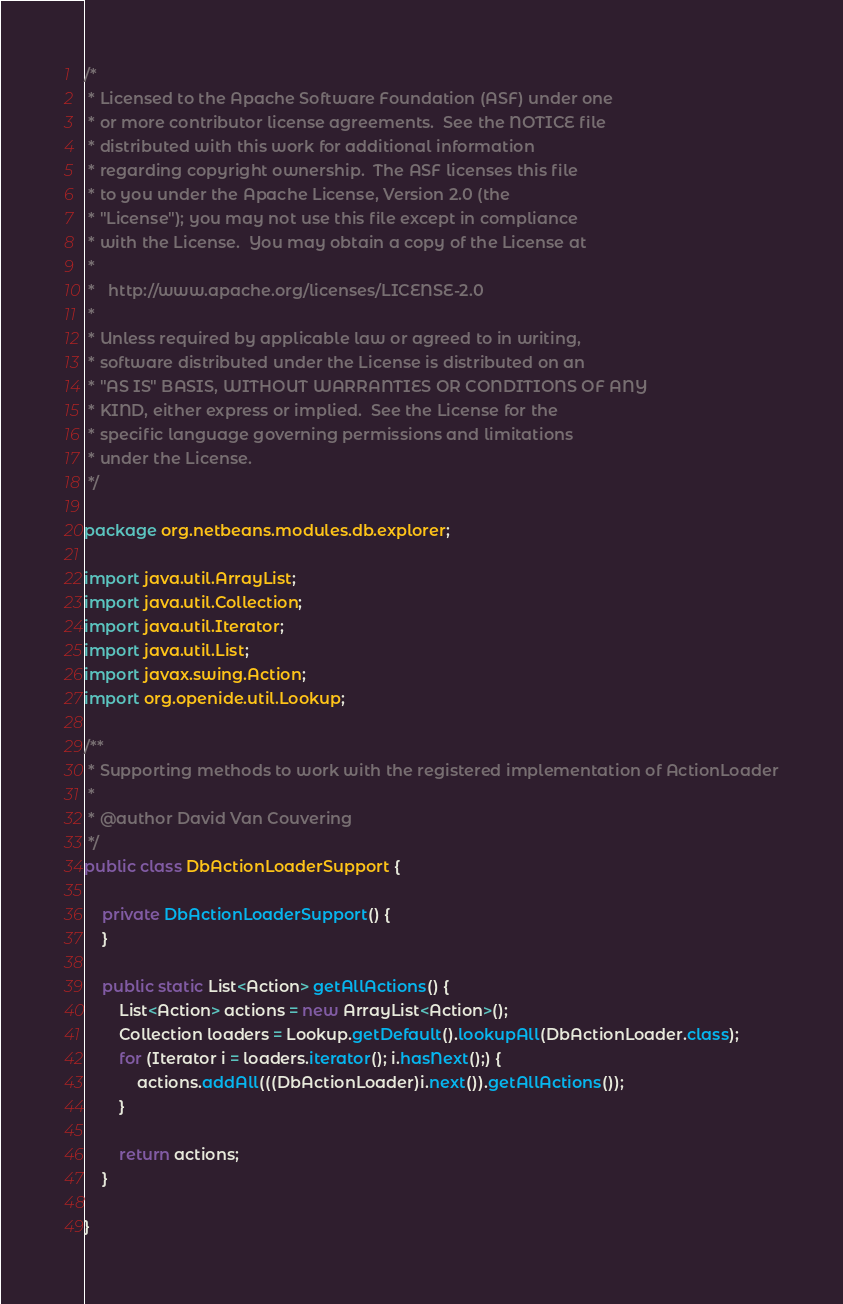<code> <loc_0><loc_0><loc_500><loc_500><_Java_>/*
 * Licensed to the Apache Software Foundation (ASF) under one
 * or more contributor license agreements.  See the NOTICE file
 * distributed with this work for additional information
 * regarding copyright ownership.  The ASF licenses this file
 * to you under the Apache License, Version 2.0 (the
 * "License"); you may not use this file except in compliance
 * with the License.  You may obtain a copy of the License at
 *
 *   http://www.apache.org/licenses/LICENSE-2.0
 *
 * Unless required by applicable law or agreed to in writing,
 * software distributed under the License is distributed on an
 * "AS IS" BASIS, WITHOUT WARRANTIES OR CONDITIONS OF ANY
 * KIND, either express or implied.  See the License for the
 * specific language governing permissions and limitations
 * under the License.
 */

package org.netbeans.modules.db.explorer;

import java.util.ArrayList;
import java.util.Collection;
import java.util.Iterator;
import java.util.List;
import javax.swing.Action;
import org.openide.util.Lookup;

/**
 * Supporting methods to work with the registered implementation of ActionLoader
 * 
 * @author David Van Couvering
 */
public class DbActionLoaderSupport {

    private DbActionLoaderSupport() {
    }

    public static List<Action> getAllActions() {
        List<Action> actions = new ArrayList<Action>();
        Collection loaders = Lookup.getDefault().lookupAll(DbActionLoader.class);
        for (Iterator i = loaders.iterator(); i.hasNext();) {
            actions.addAll(((DbActionLoader)i.next()).getAllActions());
        }
        
        return actions;
    }

}
</code> 